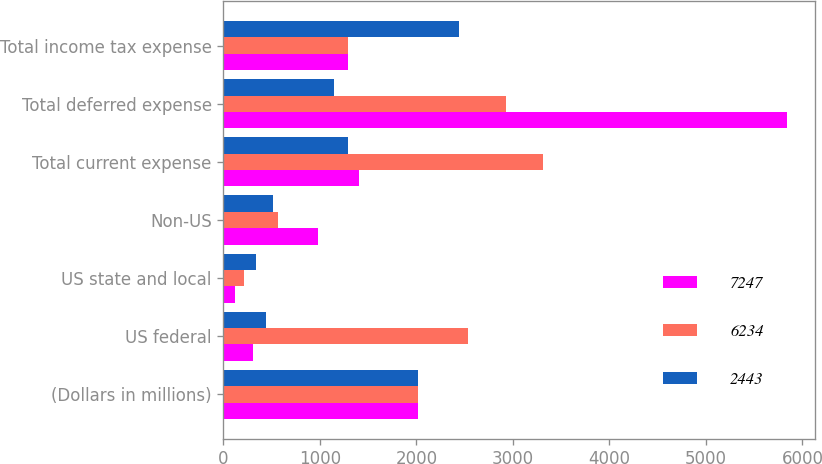Convert chart to OTSL. <chart><loc_0><loc_0><loc_500><loc_500><stacked_bar_chart><ecel><fcel>(Dollars in millions)<fcel>US federal<fcel>US state and local<fcel>Non-US<fcel>Total current expense<fcel>Total deferred expense<fcel>Total income tax expense<nl><fcel>7247<fcel>2016<fcel>302<fcel>120<fcel>984<fcel>1406<fcel>5841<fcel>1296<nl><fcel>6234<fcel>2015<fcel>2539<fcel>210<fcel>561<fcel>3310<fcel>2924<fcel>1296<nl><fcel>2443<fcel>2014<fcel>443<fcel>340<fcel>513<fcel>1296<fcel>1147<fcel>2443<nl></chart> 